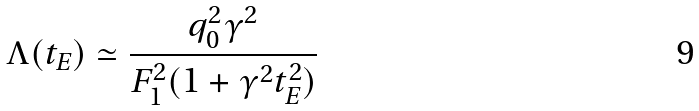Convert formula to latex. <formula><loc_0><loc_0><loc_500><loc_500>\Lambda ( t _ { E } ) \simeq \frac { q _ { 0 } ^ { 2 } \gamma ^ { 2 } } { F _ { 1 } ^ { 2 } ( 1 + \gamma ^ { 2 } t _ { E } ^ { 2 } ) }</formula> 